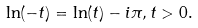Convert formula to latex. <formula><loc_0><loc_0><loc_500><loc_500>\ln ( - t ) = \ln ( t ) - i \pi , t > 0 .</formula> 